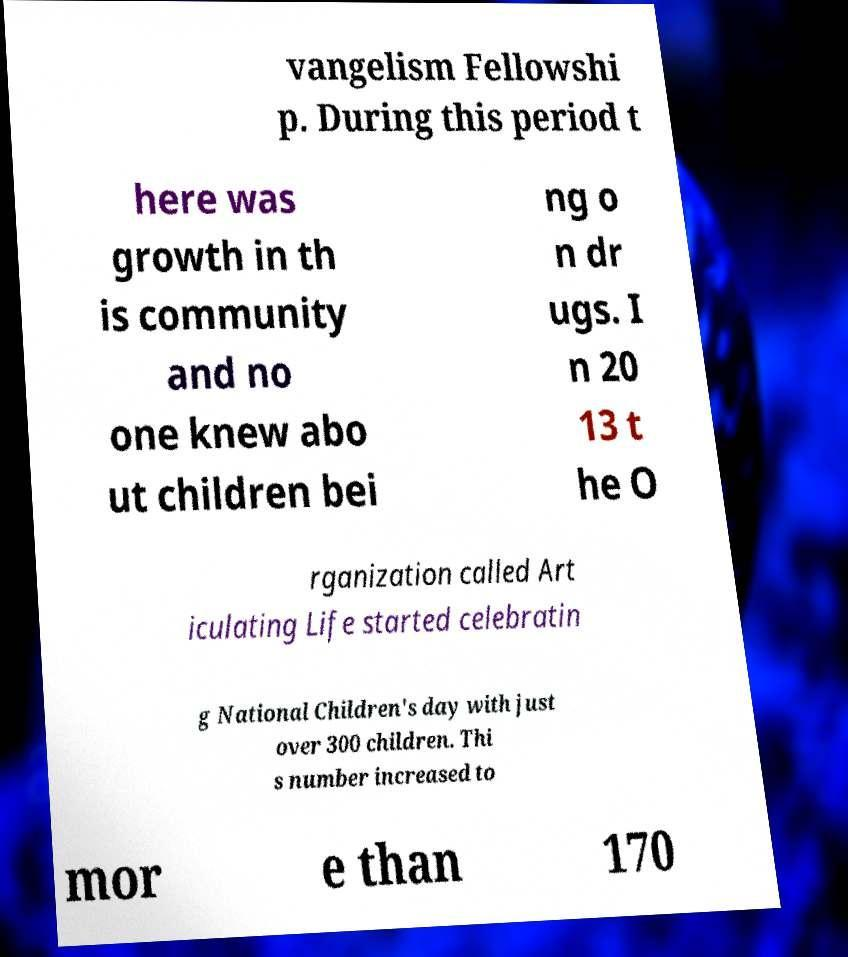What messages or text are displayed in this image? I need them in a readable, typed format. vangelism Fellowshi p. During this period t here was growth in th is community and no one knew abo ut children bei ng o n dr ugs. I n 20 13 t he O rganization called Art iculating Life started celebratin g National Children's day with just over 300 children. Thi s number increased to mor e than 170 